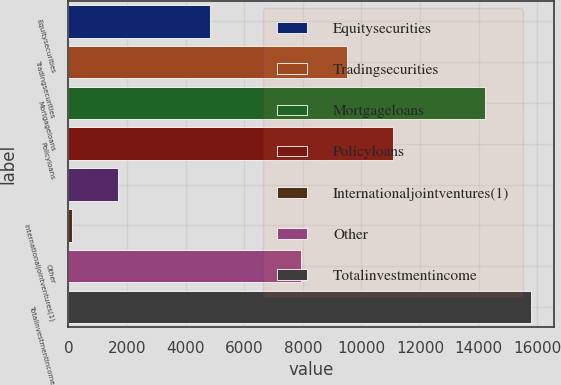<chart> <loc_0><loc_0><loc_500><loc_500><bar_chart><fcel>Equitysecurities<fcel>Tradingsecurities<fcel>Mortgageloans<fcel>Policyloans<fcel>Unnamed: 4<fcel>Internationaljointventures(1)<fcel>Other<fcel>Totalinvestmentincome<nl><fcel>4815.4<fcel>9515.8<fcel>14216.2<fcel>11082.6<fcel>1681.8<fcel>115<fcel>7949<fcel>15783<nl></chart> 